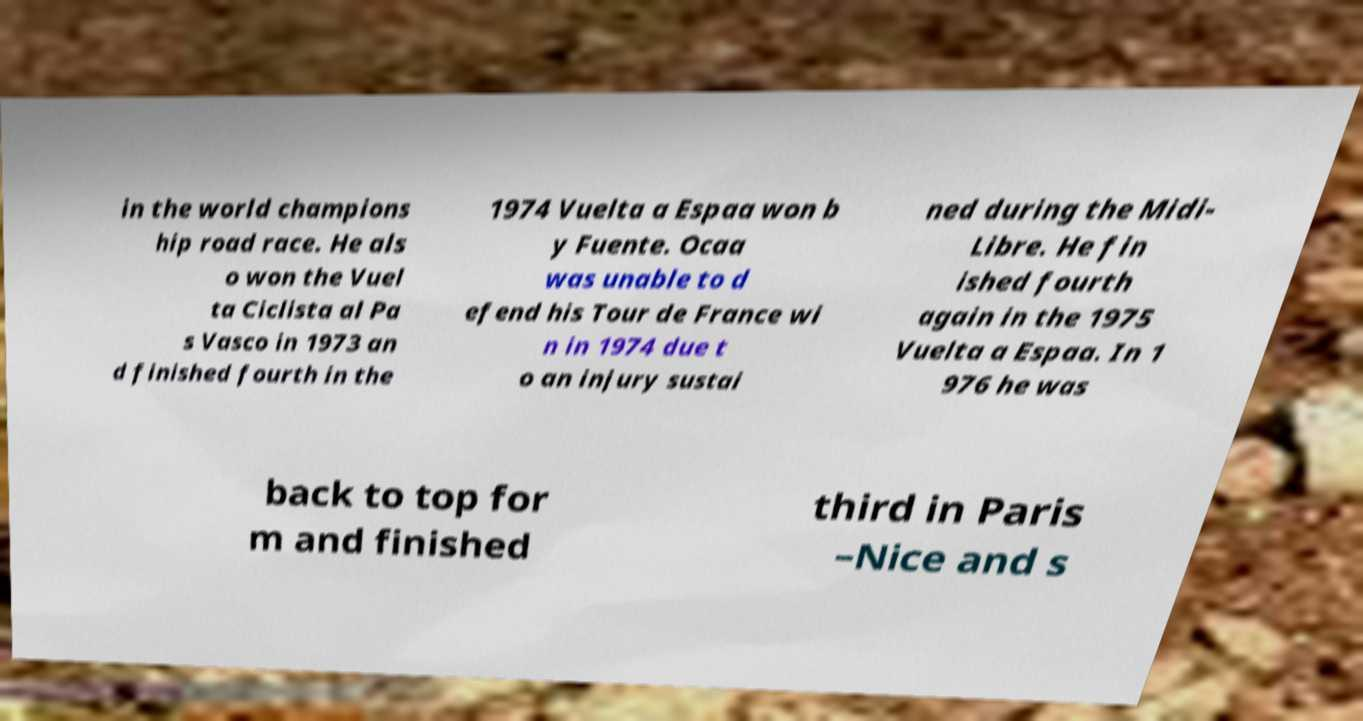Please read and relay the text visible in this image. What does it say? in the world champions hip road race. He als o won the Vuel ta Ciclista al Pa s Vasco in 1973 an d finished fourth in the 1974 Vuelta a Espaa won b y Fuente. Ocaa was unable to d efend his Tour de France wi n in 1974 due t o an injury sustai ned during the Midi- Libre. He fin ished fourth again in the 1975 Vuelta a Espaa. In 1 976 he was back to top for m and finished third in Paris –Nice and s 